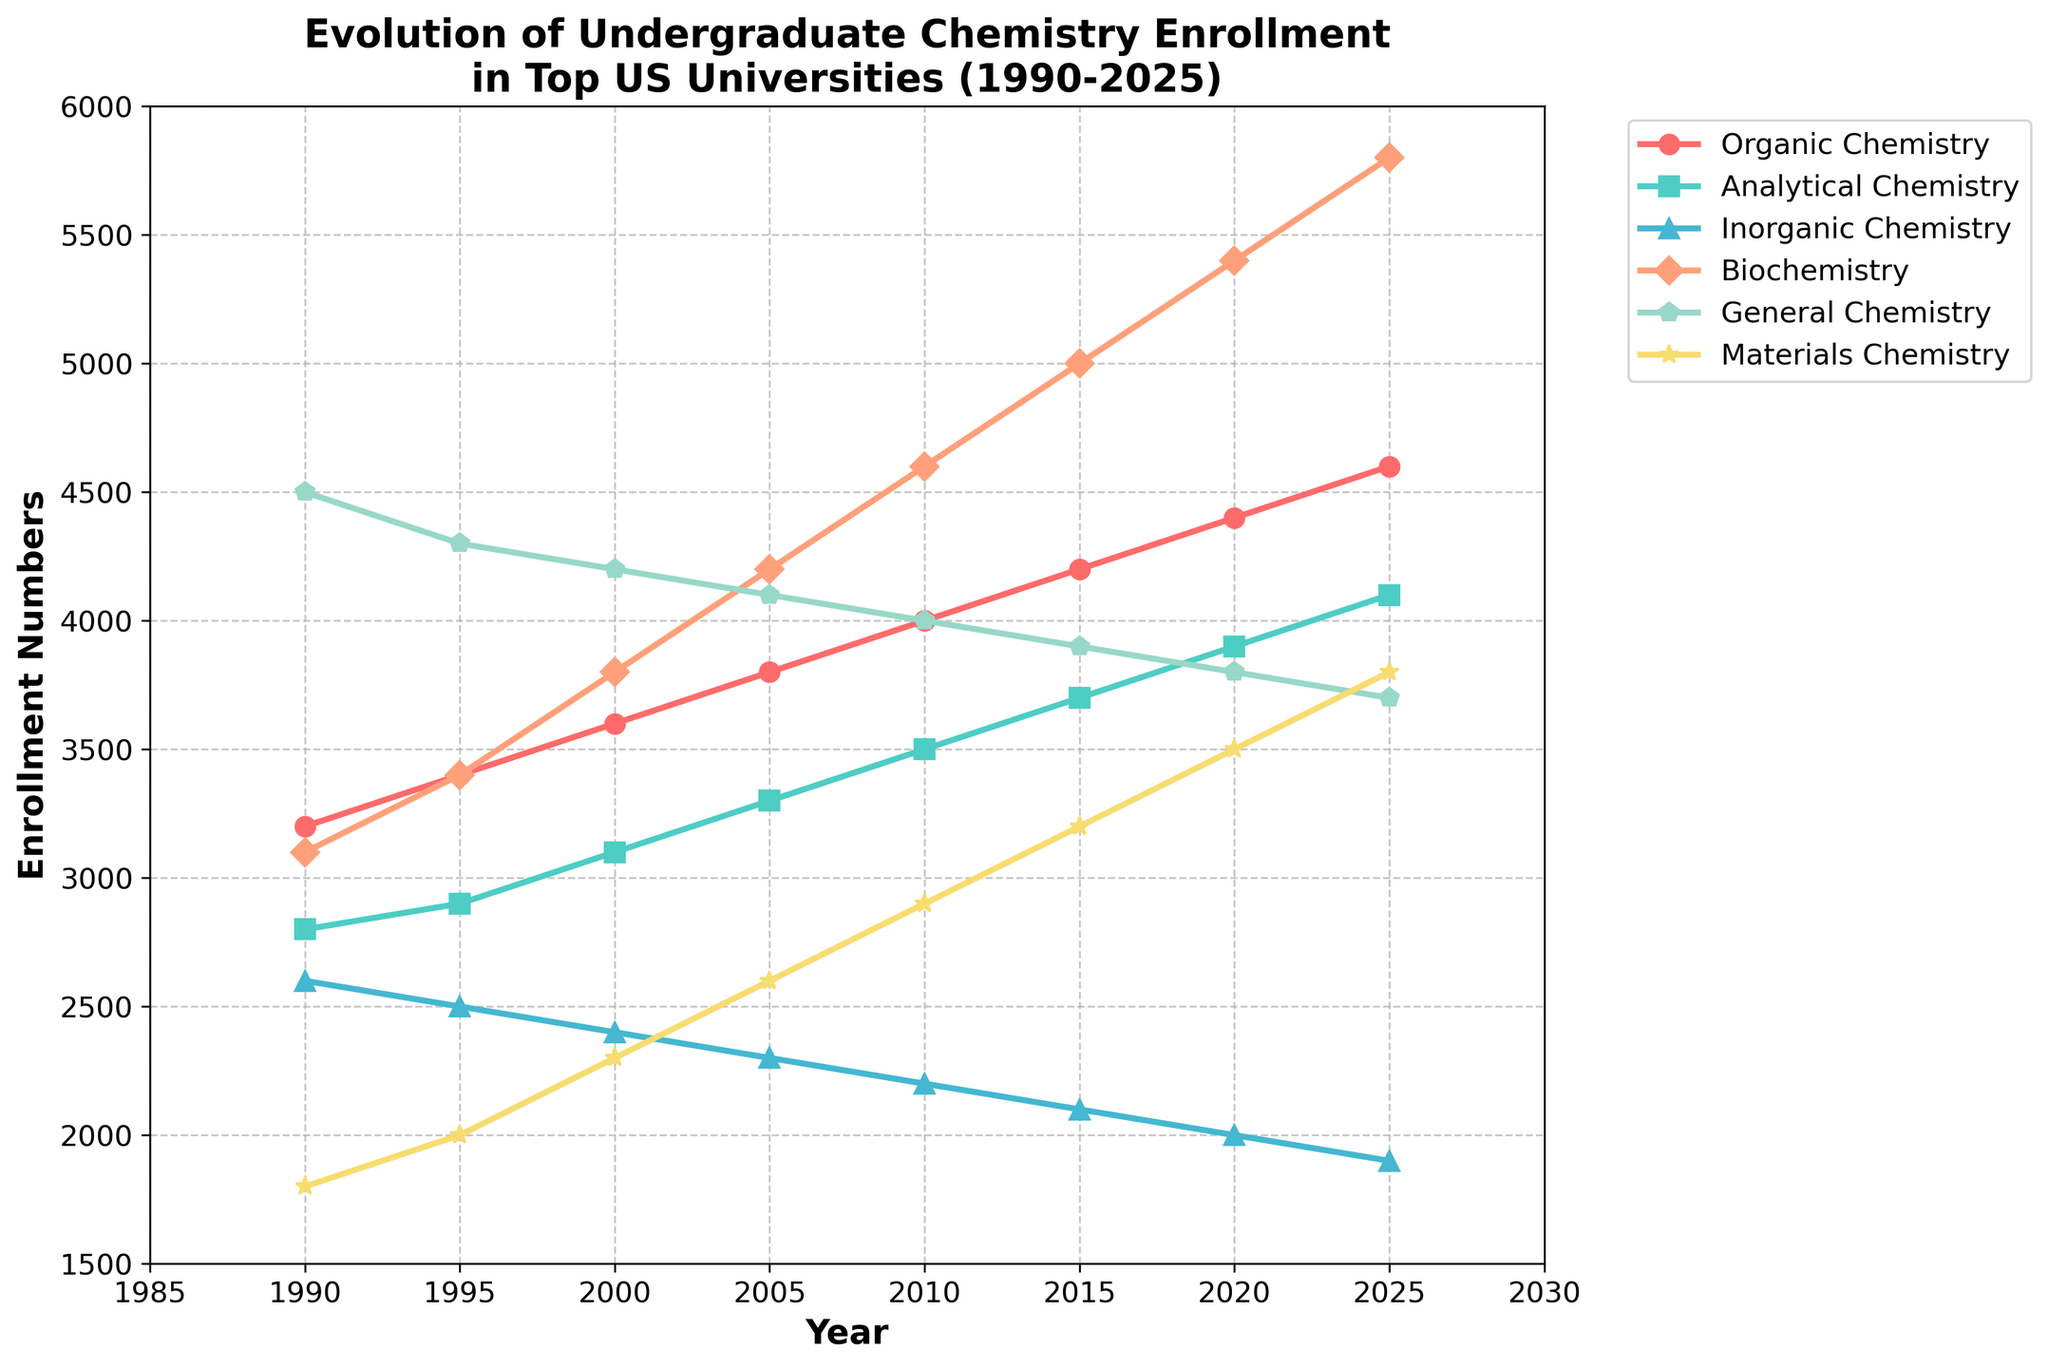Which specialization had the highest enrollment numbers in 1990? Look at the 1990 point for each specialization line, and the highest value among them is for General Chemistry at 4500.
Answer: General Chemistry How did the number of enrollments in Biochemistry change from 2000 to 2020? Check the values for Biochemistry in 2000 and 2020, which are 3800 and 5400 respectively. The difference is 5400 - 3800.
Answer: Increased by 1600 In which year did the enrollment numbers for Organic Chemistry and Biochemistry both reach 4200? Locate the lines for Organic Chemistry and Biochemistry and find the year where both lines cross 4200. That year is 2005 for Organic Chemistry and 2015 for Biochemistry.
Answer: 2015 Which specialization had the least increase in enrollment from 1990 to 2025? Calculate the difference from 1990 to 2025 for each specialization and find the smallest one. For Inorganic Chemistry, the increase is 1900 - 2600 = -700, which is the least change.
Answer: Inorganic Chemistry In 2010, which specialization had a higher enrollment number: Analytical Chemistry or Materials Chemistry? Compare the values for 2010 for both specializations: Analytical Chemistry is 3500 and Materials Chemistry is 2900.
Answer: Analytical Chemistry Over the period from 1990 to 2025, which specialization consistently decreased in enrollment? Look at the trend lines of each specialization and identify which line consistently slopes downward. Inorganic Chemistry shows a consistent decrease.
Answer: Inorganic Chemistry Between 1995 and 2015, how did the enrollment numbers for General Chemistry change? Check the values for General Chemistry in 1995 and 2015, which are 4300 and 3900 respectively. The difference is 3900 - 4300.
Answer: Decreased by 400 For the year 2005, rank the specializations by enrollment numbers from highest to lowest. Look at the enrollment numbers for each specialization in 2005 and rank them: General Chemistry (4100), Biochemistry (4200), Organic Chemistry (3800), Analytical Chemistry (3300), Materials Chemistry (2600), Inorganic Chemistry (2300).
Answer: General Chemistry > Biochemistry > Organic Chemistry > Analytical Chemistry > Materials Chemistry > Inorganic Chemistry 